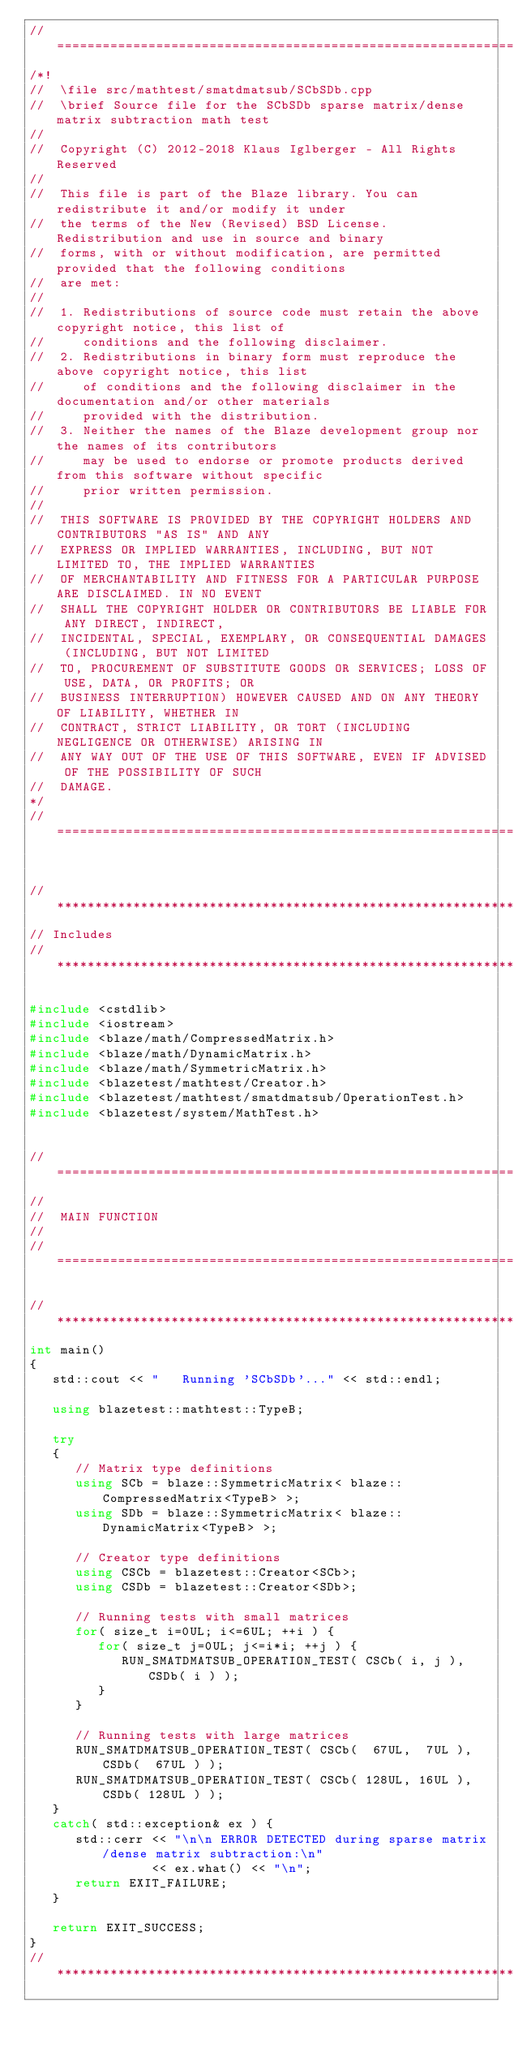<code> <loc_0><loc_0><loc_500><loc_500><_C++_>//=================================================================================================
/*!
//  \file src/mathtest/smatdmatsub/SCbSDb.cpp
//  \brief Source file for the SCbSDb sparse matrix/dense matrix subtraction math test
//
//  Copyright (C) 2012-2018 Klaus Iglberger - All Rights Reserved
//
//  This file is part of the Blaze library. You can redistribute it and/or modify it under
//  the terms of the New (Revised) BSD License. Redistribution and use in source and binary
//  forms, with or without modification, are permitted provided that the following conditions
//  are met:
//
//  1. Redistributions of source code must retain the above copyright notice, this list of
//     conditions and the following disclaimer.
//  2. Redistributions in binary form must reproduce the above copyright notice, this list
//     of conditions and the following disclaimer in the documentation and/or other materials
//     provided with the distribution.
//  3. Neither the names of the Blaze development group nor the names of its contributors
//     may be used to endorse or promote products derived from this software without specific
//     prior written permission.
//
//  THIS SOFTWARE IS PROVIDED BY THE COPYRIGHT HOLDERS AND CONTRIBUTORS "AS IS" AND ANY
//  EXPRESS OR IMPLIED WARRANTIES, INCLUDING, BUT NOT LIMITED TO, THE IMPLIED WARRANTIES
//  OF MERCHANTABILITY AND FITNESS FOR A PARTICULAR PURPOSE ARE DISCLAIMED. IN NO EVENT
//  SHALL THE COPYRIGHT HOLDER OR CONTRIBUTORS BE LIABLE FOR ANY DIRECT, INDIRECT,
//  INCIDENTAL, SPECIAL, EXEMPLARY, OR CONSEQUENTIAL DAMAGES (INCLUDING, BUT NOT LIMITED
//  TO, PROCUREMENT OF SUBSTITUTE GOODS OR SERVICES; LOSS OF USE, DATA, OR PROFITS; OR
//  BUSINESS INTERRUPTION) HOWEVER CAUSED AND ON ANY THEORY OF LIABILITY, WHETHER IN
//  CONTRACT, STRICT LIABILITY, OR TORT (INCLUDING NEGLIGENCE OR OTHERWISE) ARISING IN
//  ANY WAY OUT OF THE USE OF THIS SOFTWARE, EVEN IF ADVISED OF THE POSSIBILITY OF SUCH
//  DAMAGE.
*/
//=================================================================================================


//*************************************************************************************************
// Includes
//*************************************************************************************************

#include <cstdlib>
#include <iostream>
#include <blaze/math/CompressedMatrix.h>
#include <blaze/math/DynamicMatrix.h>
#include <blaze/math/SymmetricMatrix.h>
#include <blazetest/mathtest/Creator.h>
#include <blazetest/mathtest/smatdmatsub/OperationTest.h>
#include <blazetest/system/MathTest.h>


//=================================================================================================
//
//  MAIN FUNCTION
//
//=================================================================================================

//*************************************************************************************************
int main()
{
   std::cout << "   Running 'SCbSDb'..." << std::endl;

   using blazetest::mathtest::TypeB;

   try
   {
      // Matrix type definitions
      using SCb = blaze::SymmetricMatrix< blaze::CompressedMatrix<TypeB> >;
      using SDb = blaze::SymmetricMatrix< blaze::DynamicMatrix<TypeB> >;

      // Creator type definitions
      using CSCb = blazetest::Creator<SCb>;
      using CSDb = blazetest::Creator<SDb>;

      // Running tests with small matrices
      for( size_t i=0UL; i<=6UL; ++i ) {
         for( size_t j=0UL; j<=i*i; ++j ) {
            RUN_SMATDMATSUB_OPERATION_TEST( CSCb( i, j ), CSDb( i ) );
         }
      }

      // Running tests with large matrices
      RUN_SMATDMATSUB_OPERATION_TEST( CSCb(  67UL,  7UL ), CSDb(  67UL ) );
      RUN_SMATDMATSUB_OPERATION_TEST( CSCb( 128UL, 16UL ), CSDb( 128UL ) );
   }
   catch( std::exception& ex ) {
      std::cerr << "\n\n ERROR DETECTED during sparse matrix/dense matrix subtraction:\n"
                << ex.what() << "\n";
      return EXIT_FAILURE;
   }

   return EXIT_SUCCESS;
}
//*************************************************************************************************
</code> 